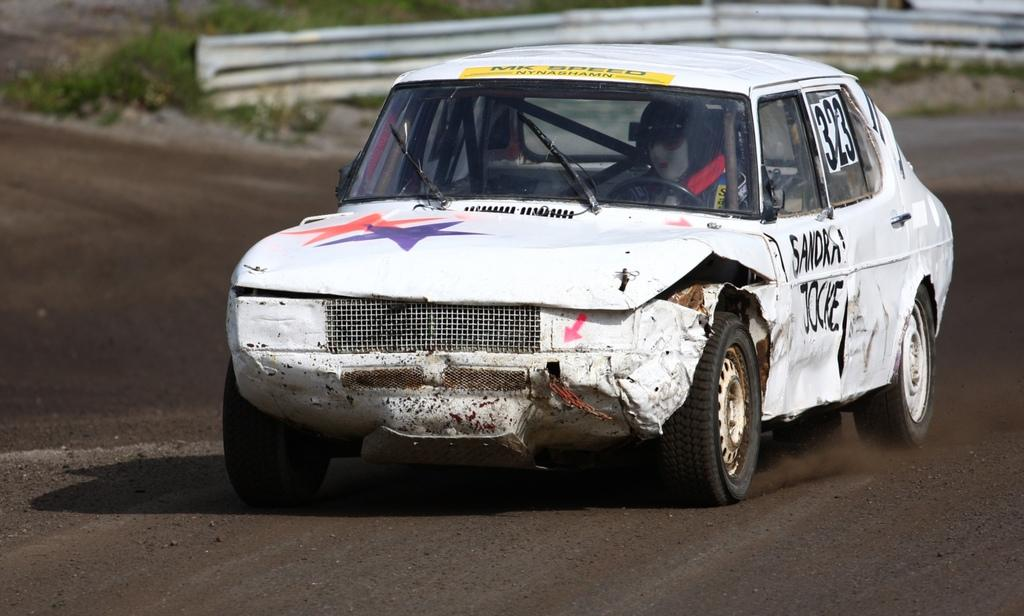What is the main subject of the image? There is a car in the center of the image. Can you describe the car's appearance? The car appears to be made of metal sheets. What can be seen in the background of the image? There is greenery in the background of the image. How does the car show respect to the sail in the image? There is no sail present in the image, and the car does not show respect or any other emotion. 